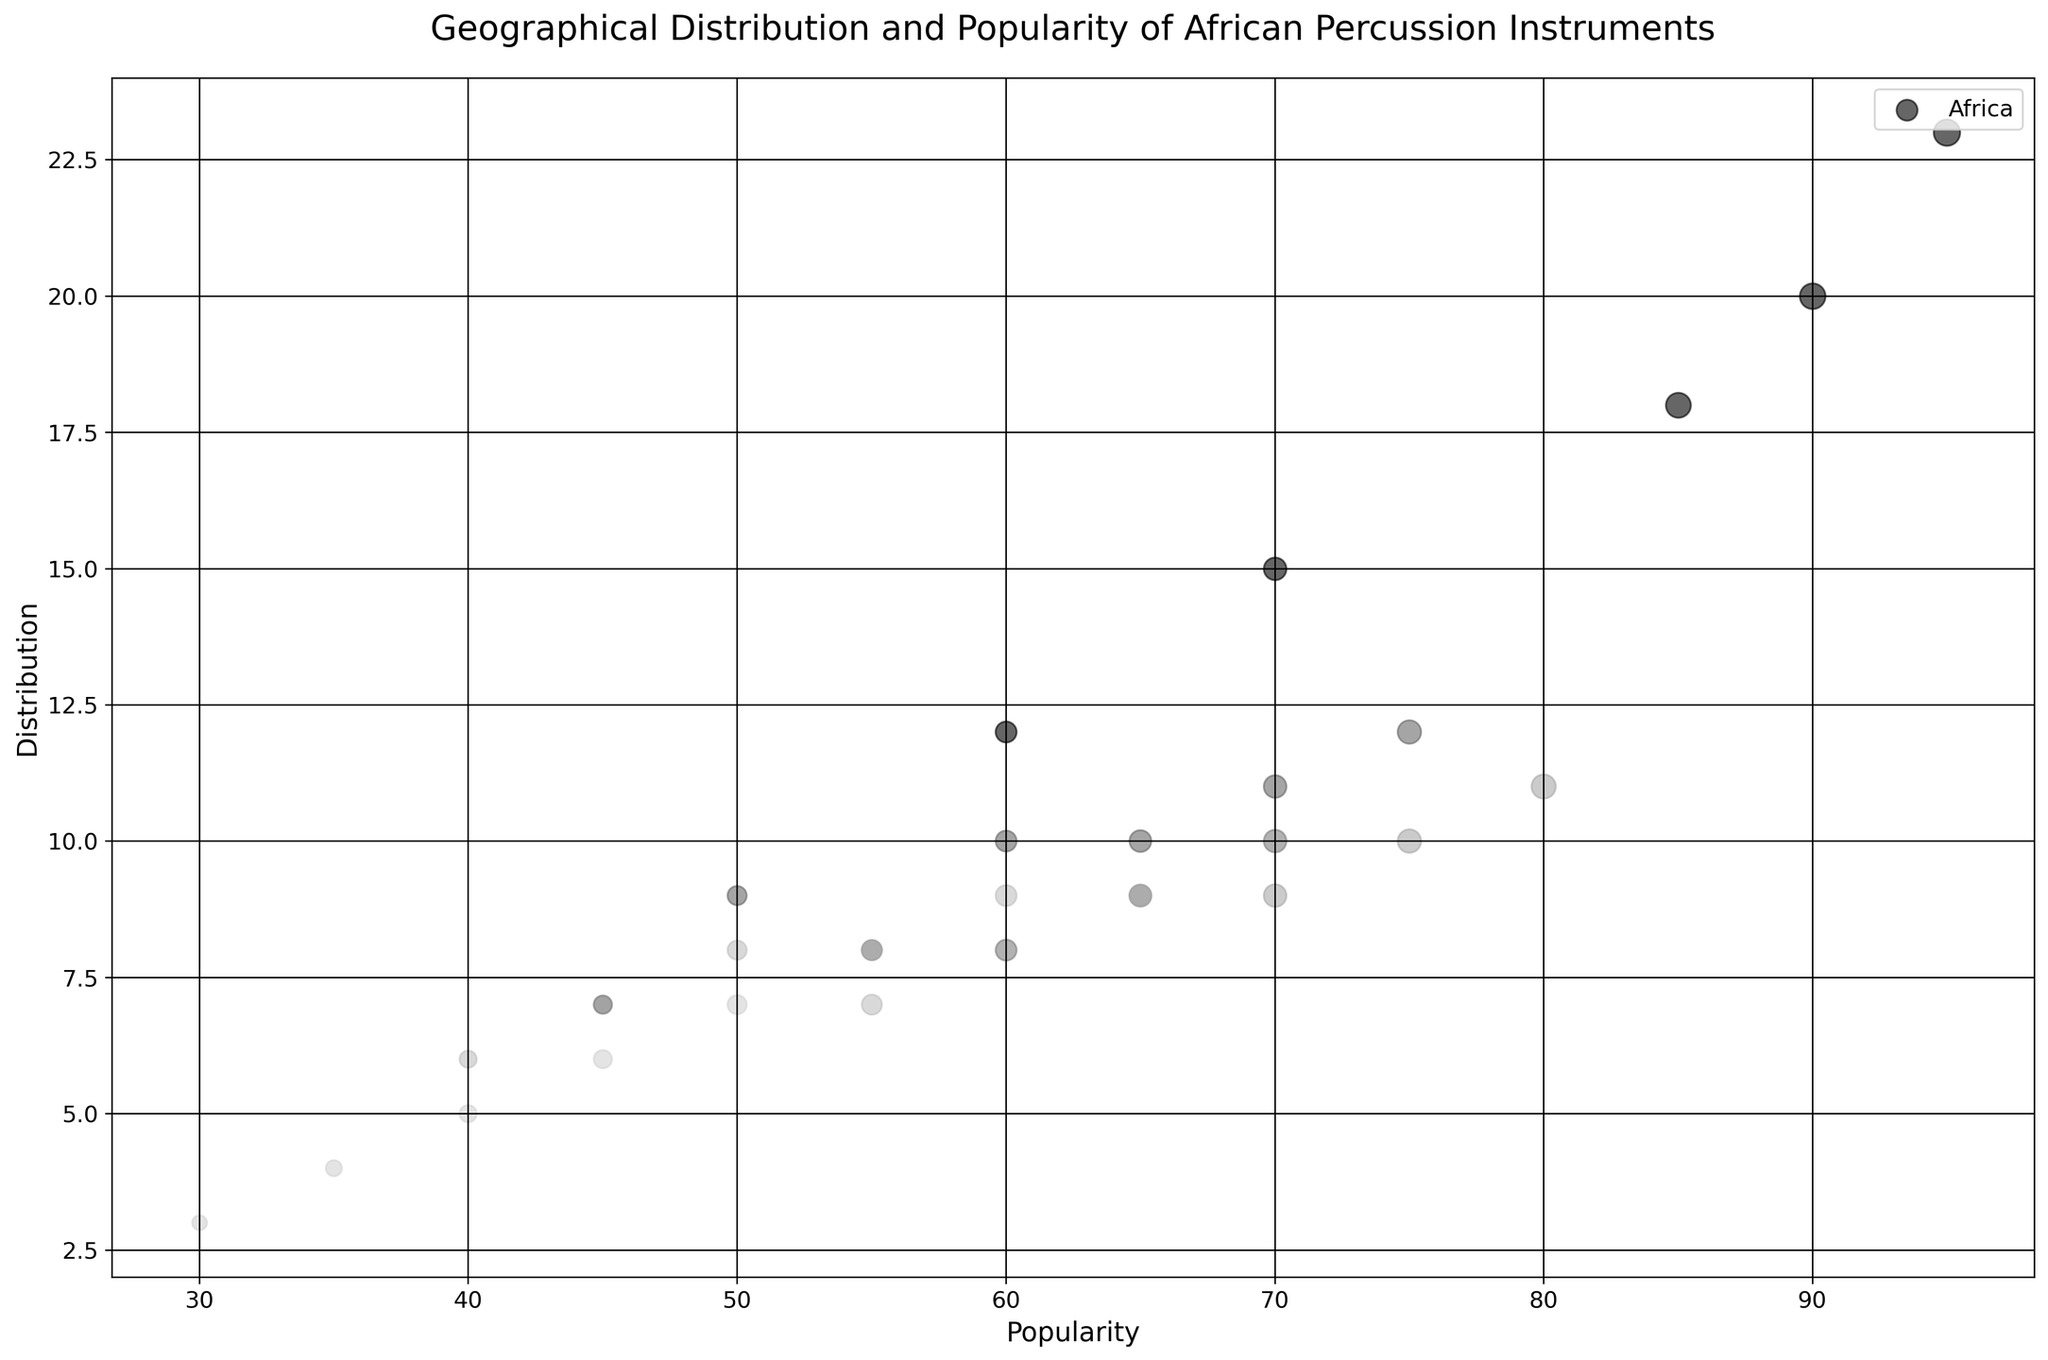What continent has the highest distribution for the Djembe? To answer this, look for the largest bubble within the color representing "Africa" corresponding to the Djembe, as Africa is always the largest. The distribution value for the Djembe in Africa is the highest.
Answer: Africa Which percussion instrument has the highest popularity in Europe? Find the bubble within the "Europe" color that has the largest size, indicating the instrument with the highest popularity. The Djembe in Europe has a popularity of 80.
Answer: Djembe What is the combined distribution for the Kalimba across all continents? Sum the distribution values for the Kalimba from all continents: (15 + 10 + 8 + 9 + 7 + 4).
Answer: 53 Which continent shows the lowest popularity for the Shekere? Identify the smallest bubble for the Shekere across all the colored continents. Oceania has the smallest bubble for the Shekere with a popularity of 45.
Answer: Oceania How does the distribution of the Talking Drum in Africa compare to that in North America? Compare the distribution values within the respective colors for Africa and North America for the Talking Drum. Africa has 18, and North America has 10.
Answer: Higher in Africa Rank the continents by the popularity of the Udu from highest to lowest. Order the bubbles by size (popularity value) for the Udu across all continents. The values are (60, 50, 45, 55, 40, 30).
Answer: Africa, Europe, North America, South America, Asia, Oceania What is the difference in popularity of the Djembe between Africa and Asia? Subtract the popularity value of the Djembe in Asia from that in Africa: 95 - 60.
Answer: 35 Which instrument in Oceania has the smallest distribution, and what is that distribution? Identify the smallest bubble for each instrument in Oceania and look for the distribution value. The Udu in Oceania has the smallest distribution of 3.
Answer: Udu, 3 Compare the distributions of the Talking Drum and Shekere in South America. Check the distribution values within the respective color for South America. Talking Drum is 8, and Shekere is 9.
Answer: Shekere has a higher distribution 